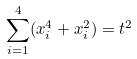<formula> <loc_0><loc_0><loc_500><loc_500>\sum _ { i = 1 } ^ { 4 } ( x _ { i } ^ { 4 } + x _ { i } ^ { 2 } ) = t ^ { 2 }</formula> 